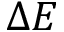Convert formula to latex. <formula><loc_0><loc_0><loc_500><loc_500>\Delta E</formula> 